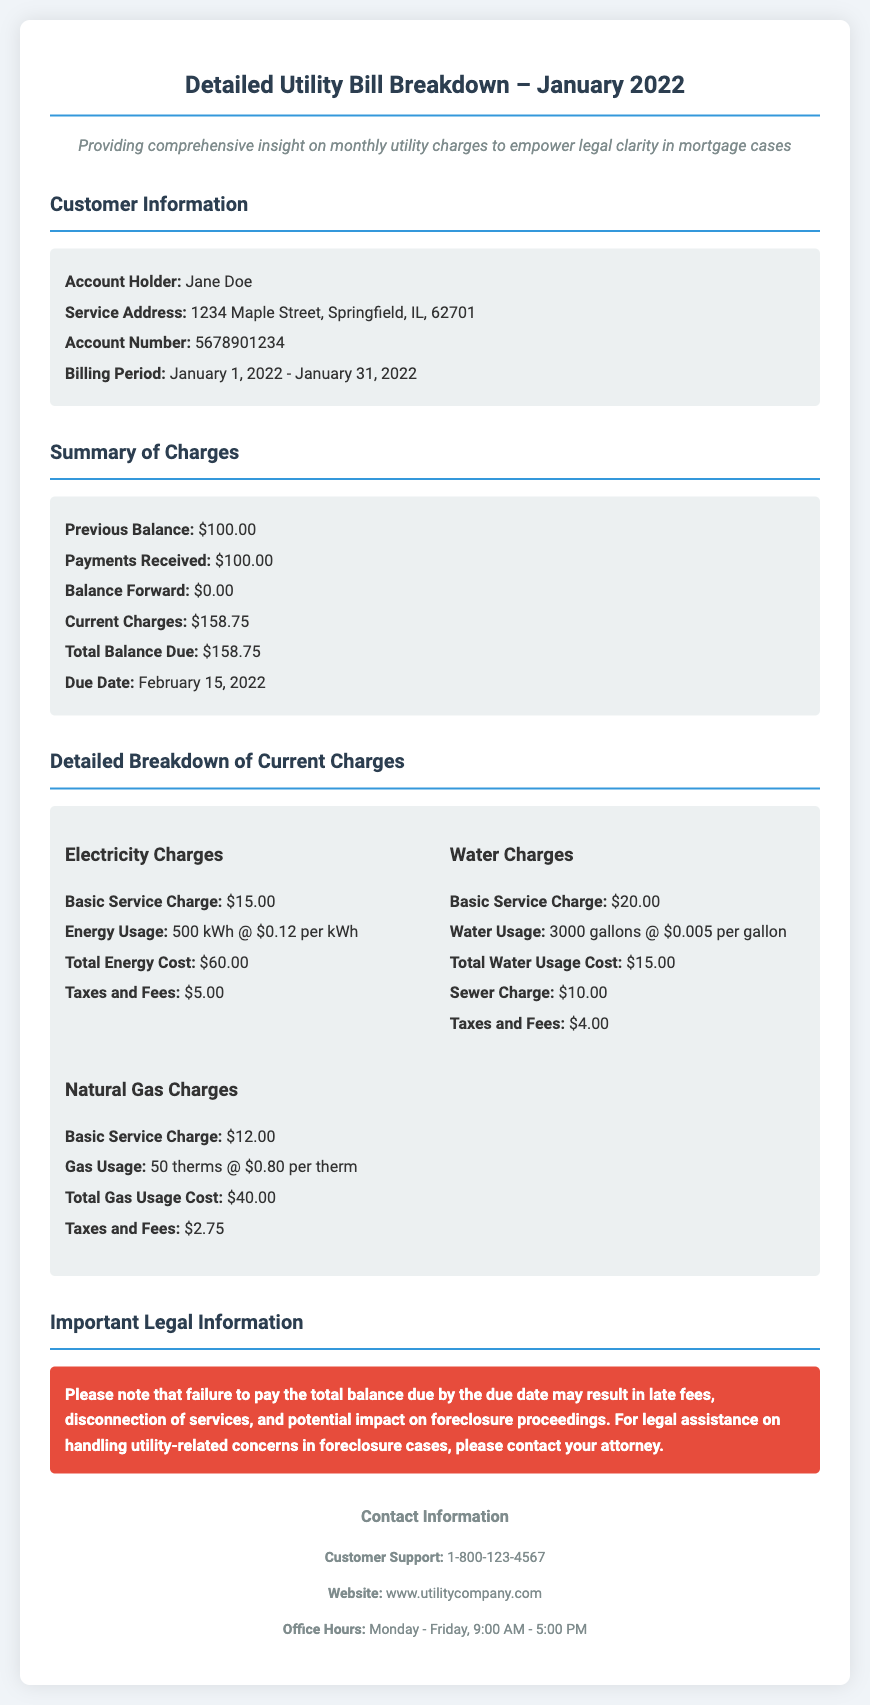What is the billing period? The billing period indicated in the document is from January 1, 2022, to January 31, 2022.
Answer: January 1, 2022 - January 31, 2022 Who is the account holder? The document specifies that the account holder is Jane Doe.
Answer: Jane Doe What is the total balance due? The total balance due according to the bill is $158.75.
Answer: $158.75 What are the electricity charges for energy usage? The energy usage charge in the detailed breakdown of electricity charges is $60.00.
Answer: $60.00 What is the due date for the payment? The due date for the payment mentioned in the document is February 15, 2022.
Answer: February 15, 2022 How much is the basic service charge for water? The basic service charge for water provided in the document is $20.00.
Answer: $20.00 What may happen if the total balance due is not paid by the due date? The document states that failure to pay may result in late fees, disconnection of services, and impact on foreclosure proceedings.
Answer: Late fees, disconnection of services, impact on foreclosure What is the customer support phone number? The customer support phone number provided in the contact information section is 1-800-123-4567.
Answer: 1-800-123-4567 How many gallons of water were used? According to the detailed breakdown, the water usage is 3000 gallons.
Answer: 3000 gallons 